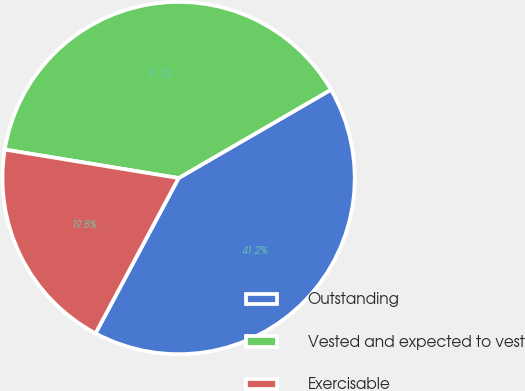Convert chart to OTSL. <chart><loc_0><loc_0><loc_500><loc_500><pie_chart><fcel>Outstanding<fcel>Vested and expected to vest<fcel>Exercisable<nl><fcel>41.18%<fcel>39.05%<fcel>19.77%<nl></chart> 